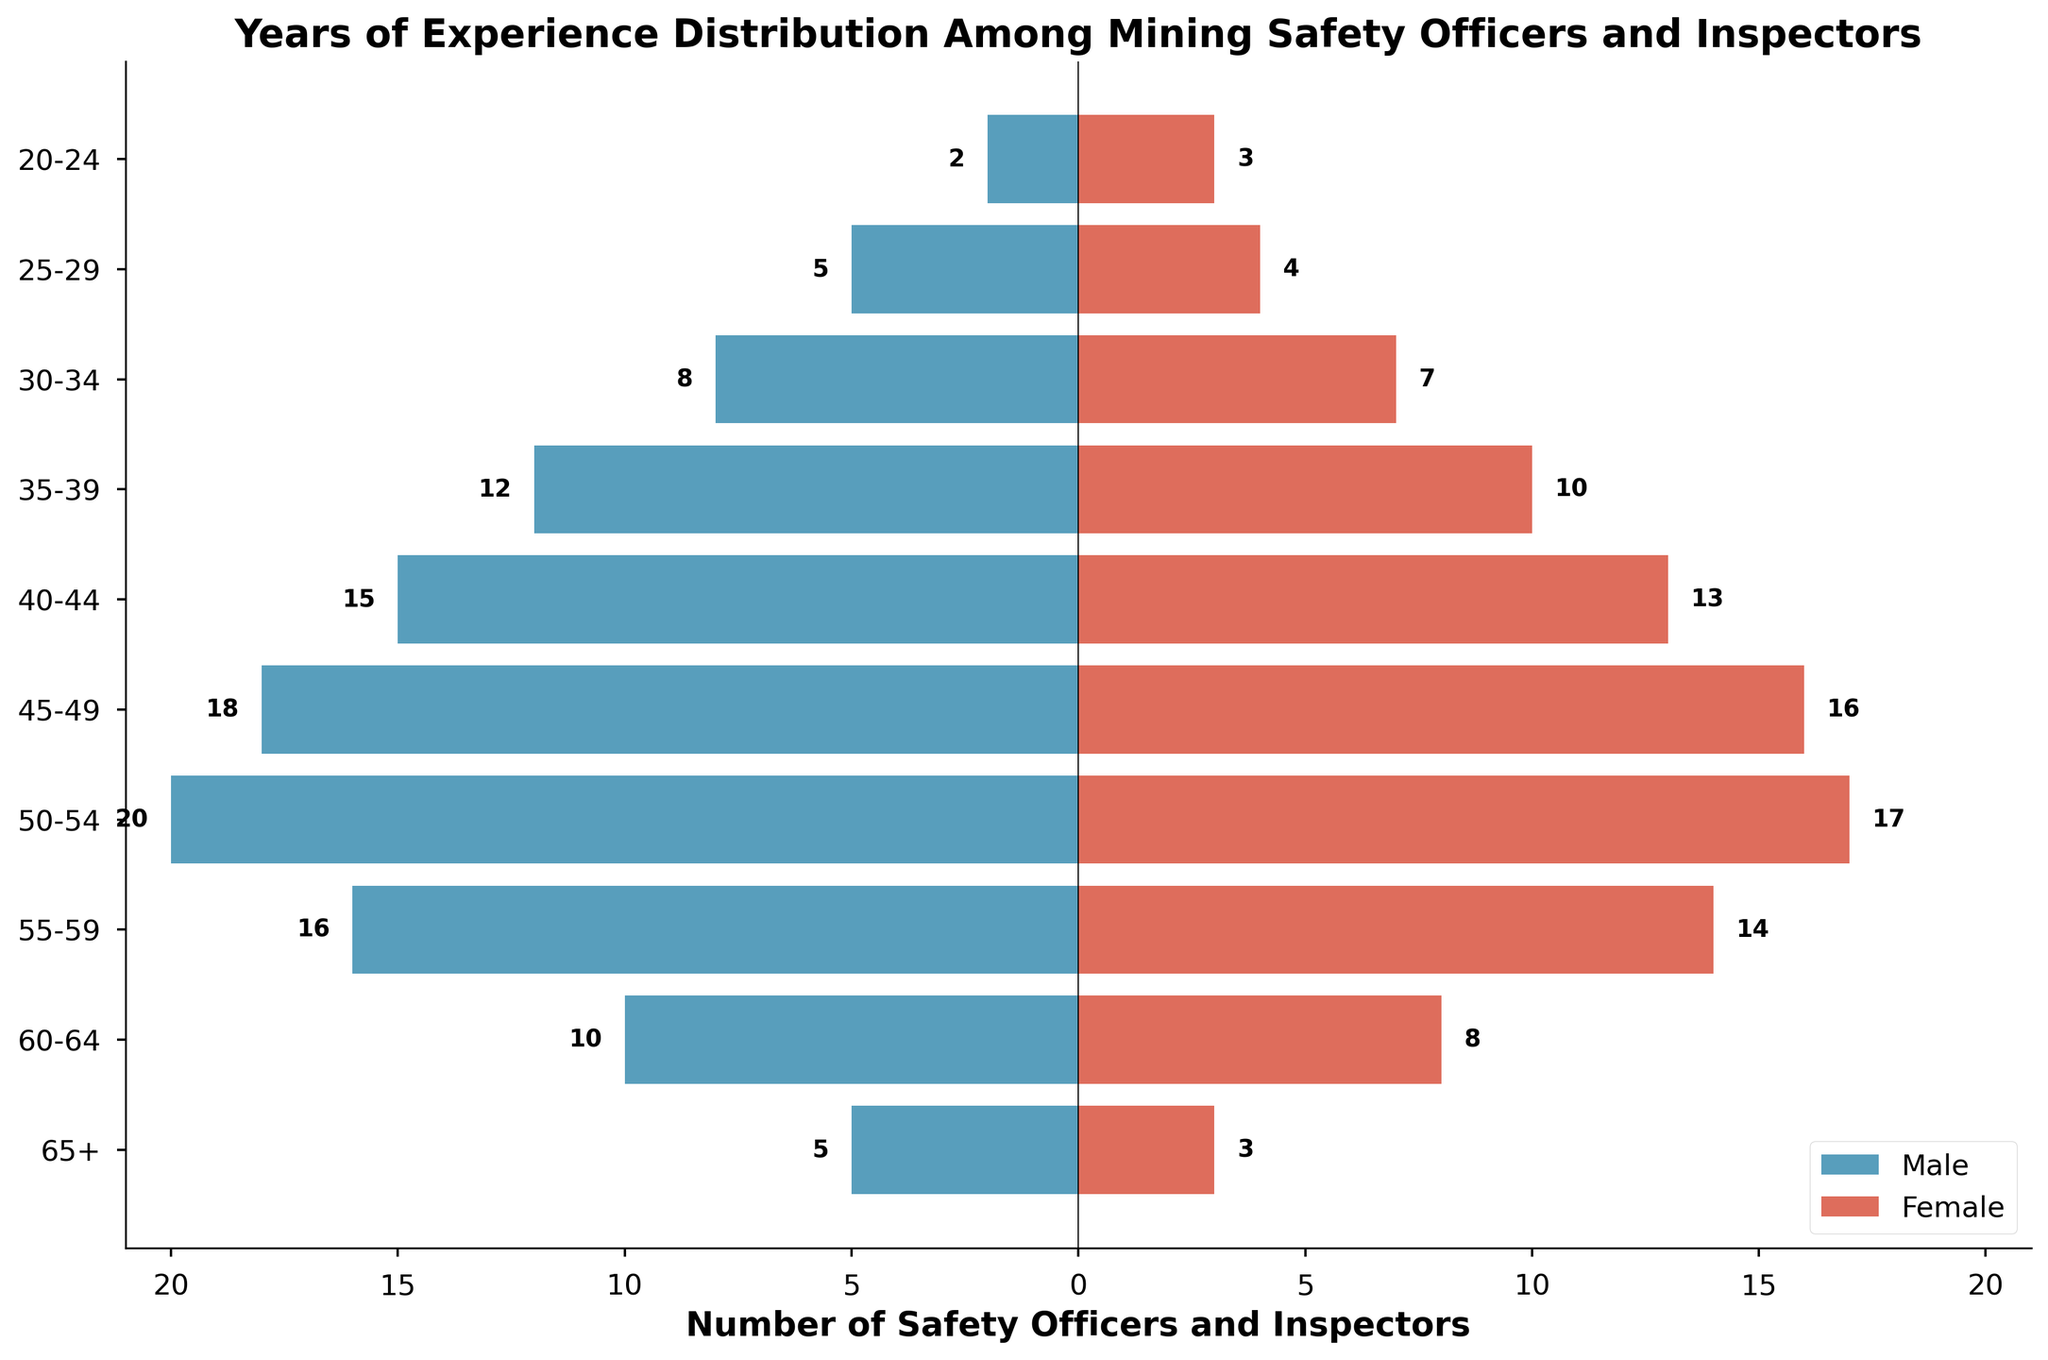What is the title of the figure? The title is usually placed at the top center of the figure, providing a brief description of the content shown.
Answer: Years of Experience Distribution Among Mining Safety Officers and Inspectors What are the two color labels used in the figure? The figure uses a color legend to indicate the groups represented. The labels are on the lower right of the plot.
Answer: Male and Female Which age range has the highest number of female mining safety officers and inspectors? Look for the age range bar extending the furthest to the right under the female label.
Answer: 50-54 How many male mining safety officers and inspectors are in the 45-49 age range? Check the length of the male bar corresponding to the 45-49 age range on the negative axis.
Answer: 18 Compare the number of male and female safety officers in the 25-29 age range. Compare the length of the bars for males and females in the 25-29 age range on the plot.
Answer: 5 males, 4 females What is the total number of mining safety officers and inspectors in the 20-24 age range? Sum the values for both males and females in the 20-24 age range.
Answer: 5 Which age range has more male safety officers than female safety officers and by how many? Check each age range where the male bar is longer than the female bar and compute the difference.
Answer: 20-24 by 1, 30-34 by 1, 35-39 by 2, 40-44 by 2, 45-49 by 2, 50-54 by 3, 55-59 by 2, 60-64 by 2, 65+ by 2 What is the combined total of male and female safety officers and inspectors in the 55-59 age range? Add the male and female values together in the 55-59 age range.
Answer: 30 For which age range is the number of mining safety officers and inspectors closest to being equal between males and females? Look for the age range where the male and female bars are closest in length. Compute the difference if needed.
Answer: 25-29 (difference of 1) What is the difference in the number of male and female mining safety officers and inspectors in the 65+ age range? Subtract the number of females in the 65+ range from the number of males.
Answer: 2 